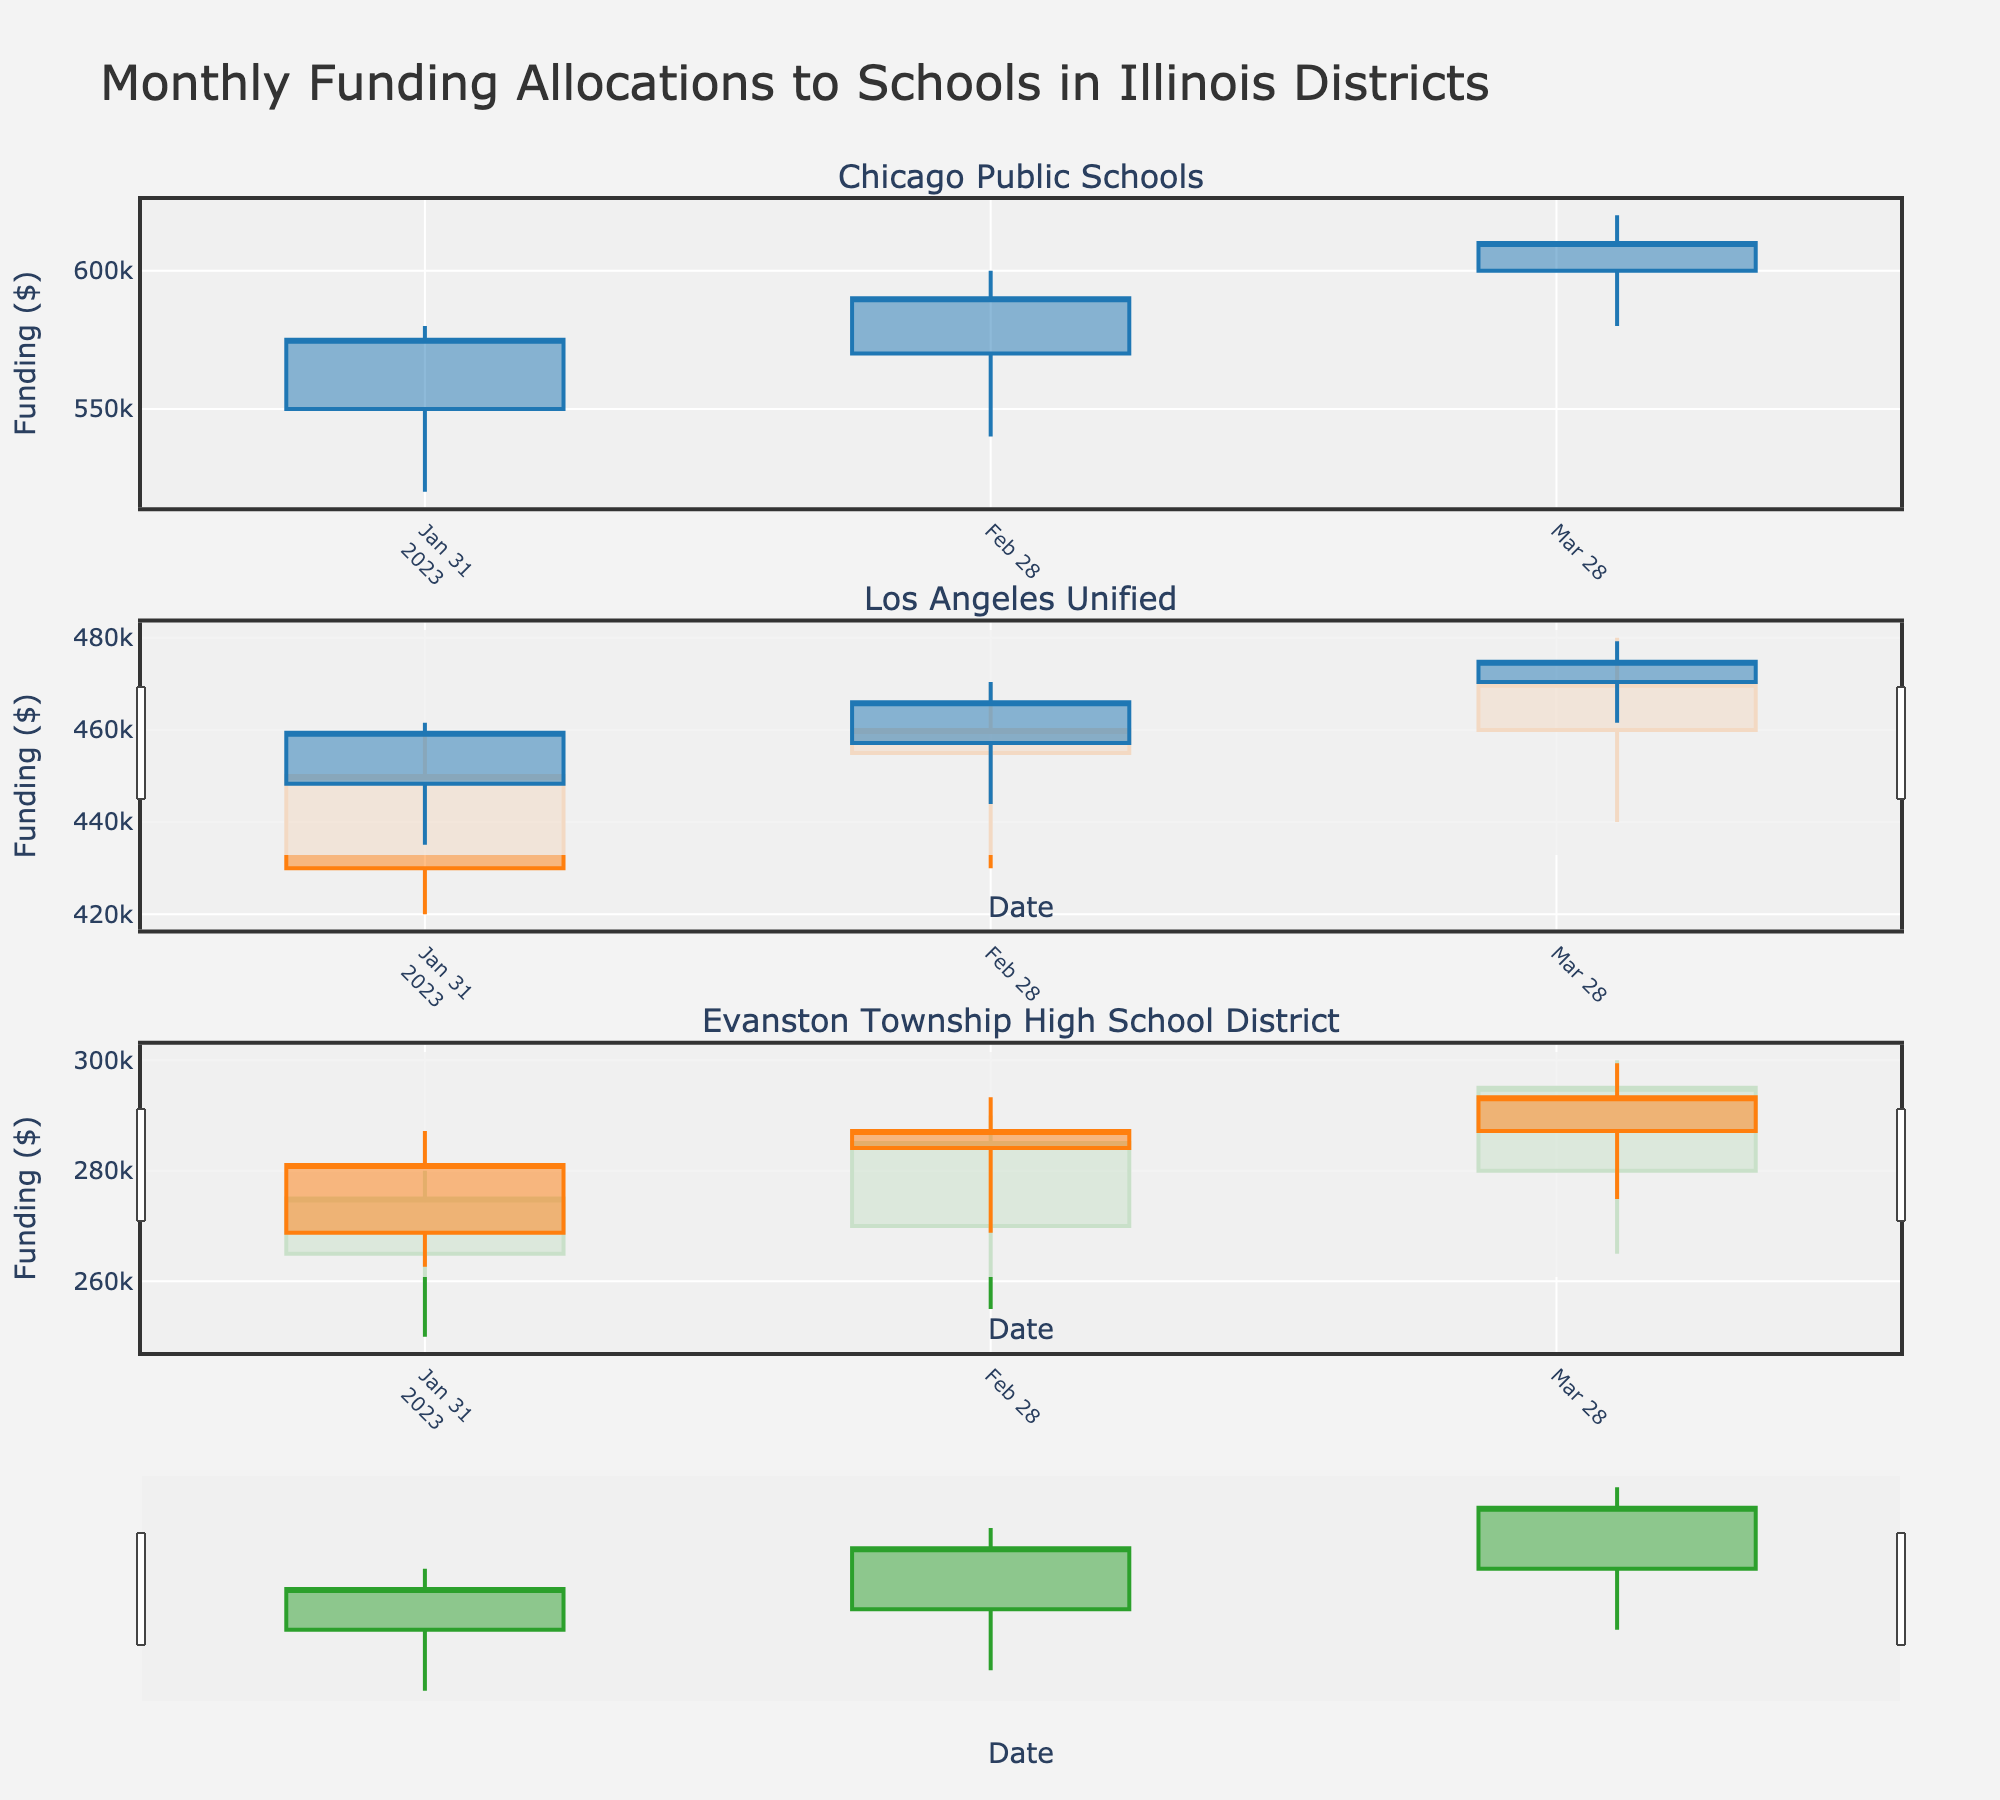what is the title of the plot? The title of the plot is prominently displayed at the top. It is a crucial piece of information that provides context for what the plot represents.
Answer: Monthly Funding Allocations to Schools in Illinois Districts How many districts are shown in the plot? Count the number of subplot titles; each represents a different district.
Answer: 3 Which district received the highest funding in January 2023? Look at the 'High' value for each district in January 2023. Compare the maximum values.
Answer: Chicago Public Schools What was the funding range for Evanston Township High School District in February 2023? Check the 'High' and 'Low' values for Evanston Township High School District in February 2023 to find the range.
Answer: $290,000 to $255,000 Did Chicago Public Schools funding increase or decrease from January to March 2023? Compare the 'Close' values of March and January.
Answer: Increase Which district had the smallest increase in funding from January to February 2023? Calculate the difference between 'Close' values of February and January for each district, and find the smallest increase.
Answer: Los Angeles Unified How does the March funding for Evanston compare to the February funding? Compare 'Close' values for Evanston Township High School District in February and March to determine if it increased, decreased, or remained the same.
Answer: Increase What is the average March funding across all districts? Calculate the average of the 'Close' values across all districts for March.
Answer: $458,333.33 What trend is visible in the funding for Los Angeles Unified from January to March 2023? Analyze the 'Close' values from January to March; observe if they are increasing, decreasing, or stable.
Answer: Increasing What is the general trend in the funding for Chicago Public Schools? Analyze the general direction of the 'Close' values over all three months.
Answer: Increasing 